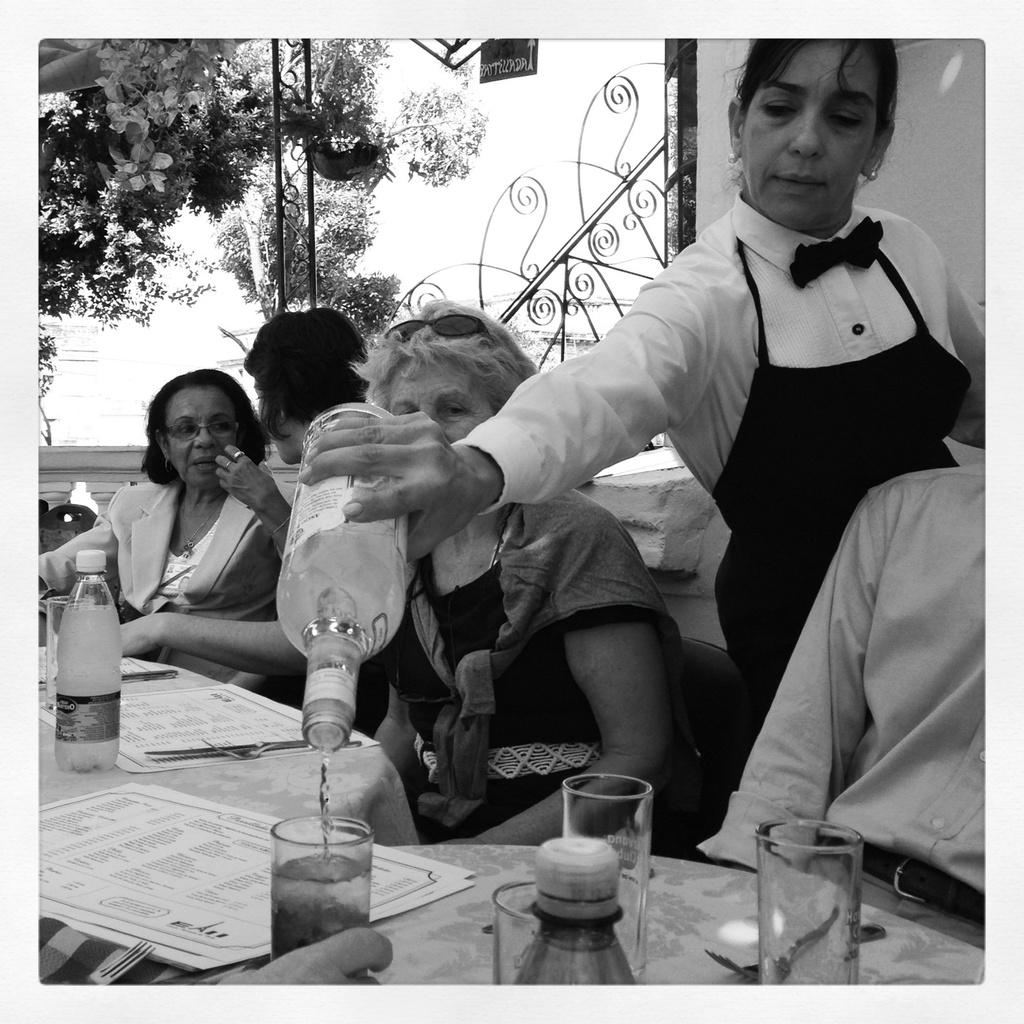Who is the main subject in the image? There is a woman in the image. What is the woman doing in the image? The woman is serving wine. What is the woman holding in the image? The woman is holding a bottle of wine. What objects are on the table in the image? There are glasses and bottles on the table. What are the people around the table doing? People are seated on chairs around the table. What can be seen in the background of the image? There is a tree visible in the image. What type of eggnog is being served in the image? There is no eggnog present in the image; the woman is serving wine. How many tigers can be seen in the image? There are no tigers present in the image. 